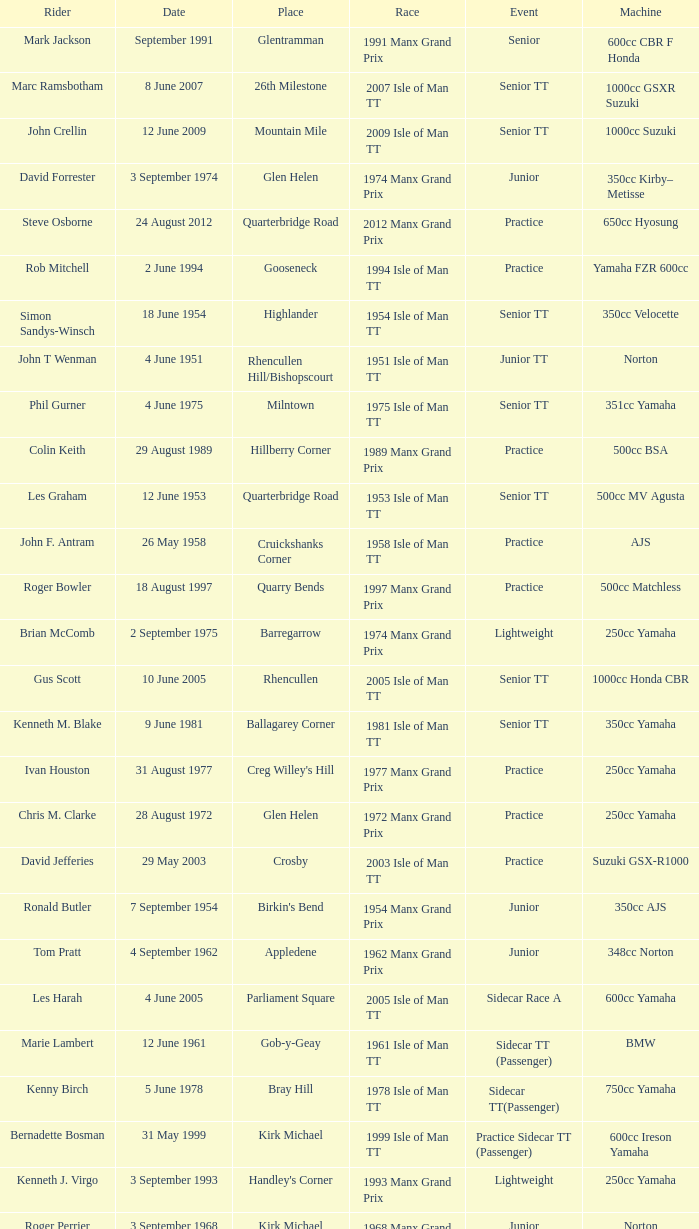Where was the 249cc Yamaha? Glentramman. 